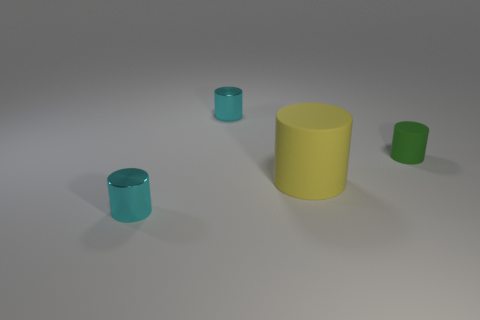There is a small metallic thing behind the yellow cylinder; does it have the same color as the matte cylinder to the right of the big matte cylinder?
Keep it short and to the point. No. What number of other objects are there of the same size as the yellow object?
Provide a short and direct response. 0. There is a small cyan cylinder behind the tiny metallic cylinder that is in front of the small green cylinder; is there a tiny matte object that is behind it?
Your response must be concise. No. Does the cylinder in front of the big yellow matte cylinder have the same material as the yellow thing?
Give a very brief answer. No. What color is the other tiny rubber thing that is the same shape as the yellow matte thing?
Ensure brevity in your answer.  Green. Are there any other things that are the same shape as the small matte object?
Your answer should be very brief. Yes. Are there an equal number of cyan objects that are behind the big matte cylinder and big yellow matte cylinders?
Your response must be concise. Yes. There is a big matte object; are there any cyan shiny cylinders to the right of it?
Your answer should be compact. No. How big is the cyan thing that is on the right side of the tiny cylinder that is on the left side of the cyan metallic cylinder that is behind the small rubber object?
Provide a succinct answer. Small. There is a tiny cyan object behind the yellow rubber object; is its shape the same as the shiny object that is in front of the tiny green rubber thing?
Offer a very short reply. Yes. 